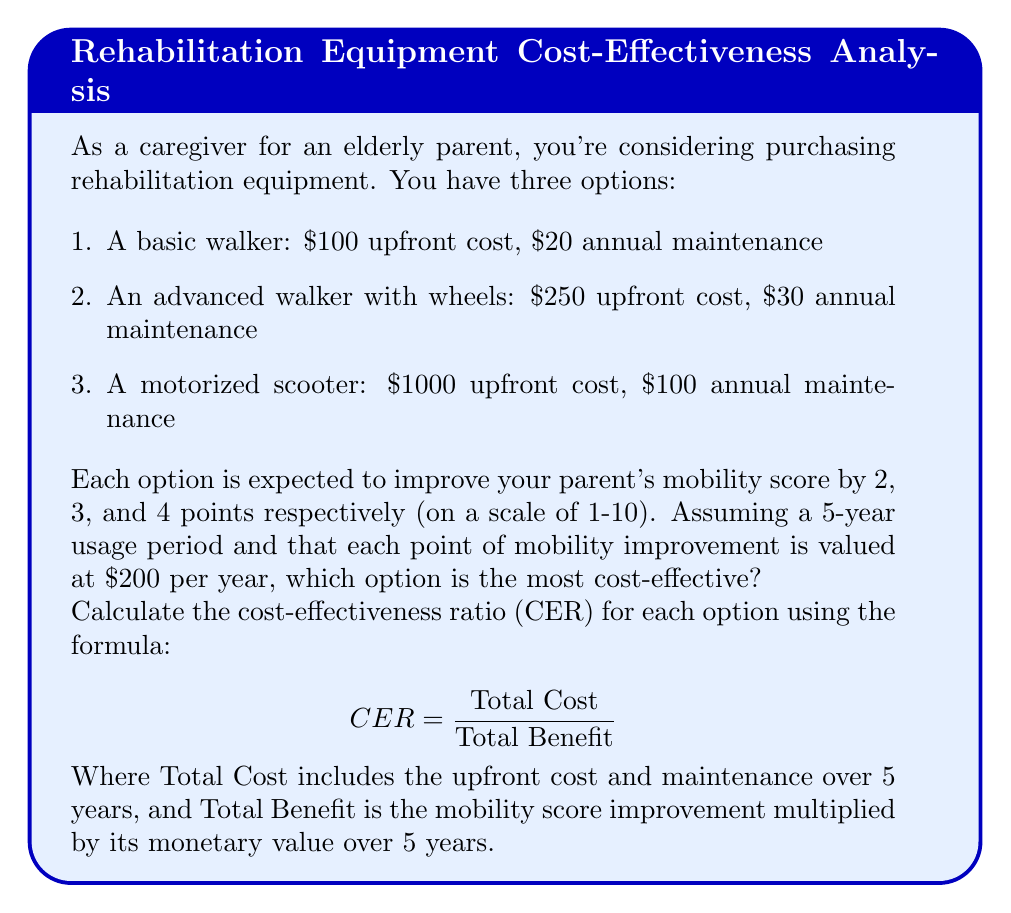Could you help me with this problem? Let's calculate the CER for each option:

1. Basic walker:
   Total Cost = $100 + ($20 × 5) = $200
   Total Benefit = 2 × $200 × 5 = $2000
   $$ CER_{basic} = \frac{200}{2000} = 0.1 $$

2. Advanced walker:
   Total Cost = $250 + ($30 × 5) = $400
   Total Benefit = 3 × $200 × 5 = $3000
   $$ CER_{advanced} = \frac{400}{3000} \approx 0.133 $$

3. Motorized scooter:
   Total Cost = $1000 + ($100 × 5) = $1500
   Total Benefit = 4 × $200 × 5 = $4000
   $$ CER_{scooter} = \frac{1500}{4000} = 0.375 $$

The option with the lowest CER is the most cost-effective. In this case, the basic walker has the lowest CER at 0.1, making it the most cost-effective option.
Answer: The basic walker is the most cost-effective option with a CER of 0.1. 